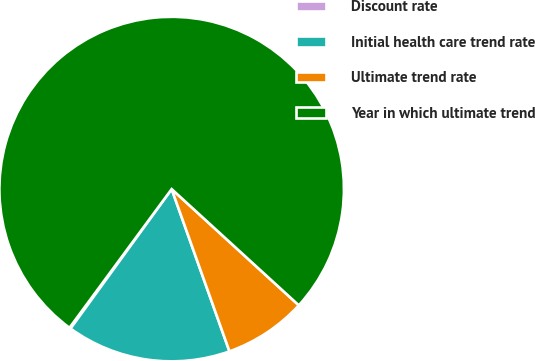Convert chart. <chart><loc_0><loc_0><loc_500><loc_500><pie_chart><fcel>Discount rate<fcel>Initial health care trend rate<fcel>Ultimate trend rate<fcel>Year in which ultimate trend<nl><fcel>0.12%<fcel>15.43%<fcel>7.77%<fcel>76.68%<nl></chart> 